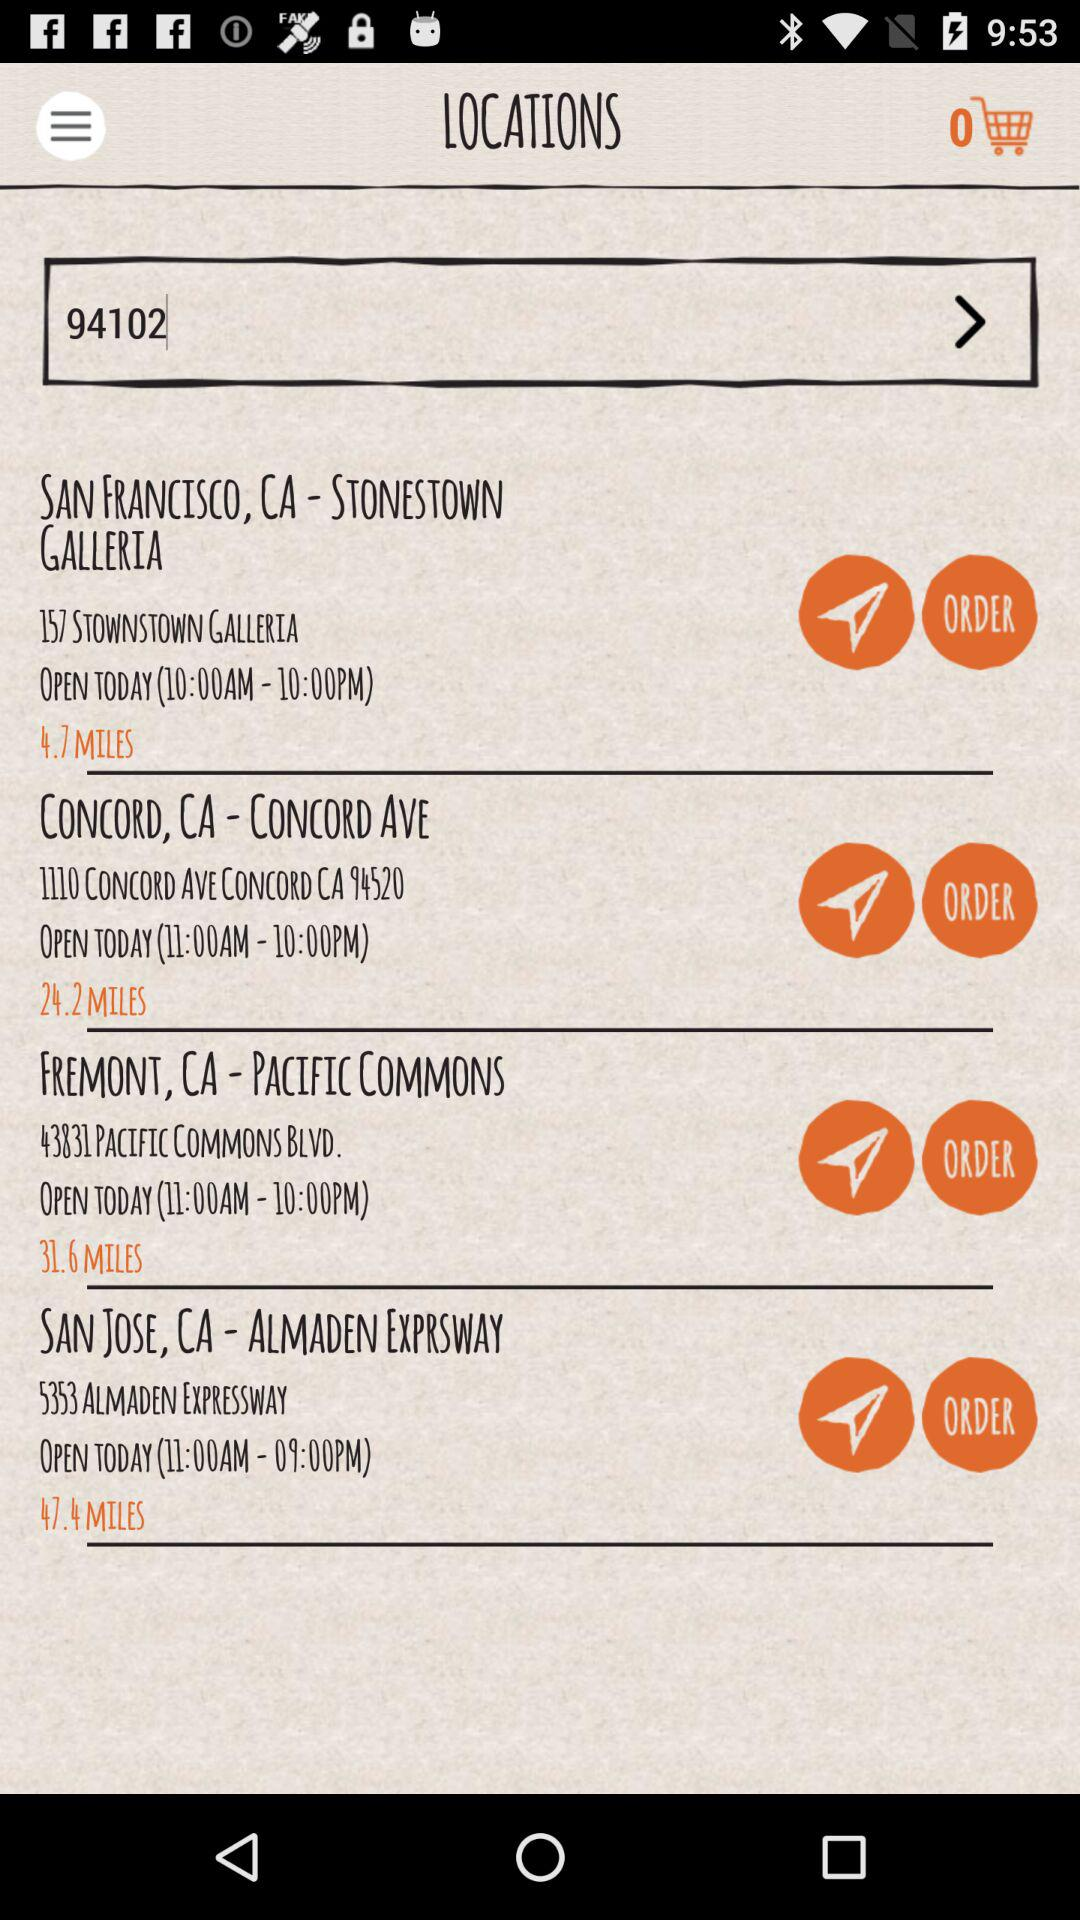How many items are there in the cart? There is 0 item. 